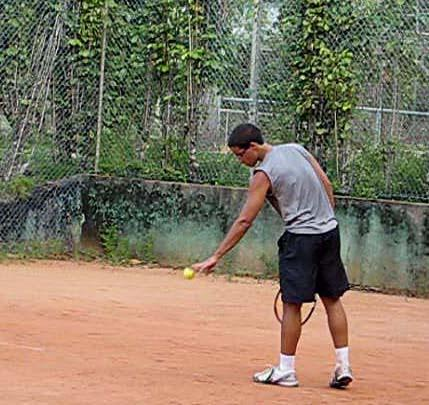Question: who is playing tennis?
Choices:
A. A little boy.
B. A man.
C. A woman.
D. A baker.
Answer with the letter. Answer: B Question: why is the man holding a racket?
Choices:
A. To defend himself.
B. To attack someone.
C. To do a trick.
D. To hit the ball.
Answer with the letter. Answer: D Question: where was this picture taken?
Choices:
A. A baseball field.
B. A volleyball court.
C. A hockey rink.
D. A tennis court.
Answer with the letter. Answer: D 